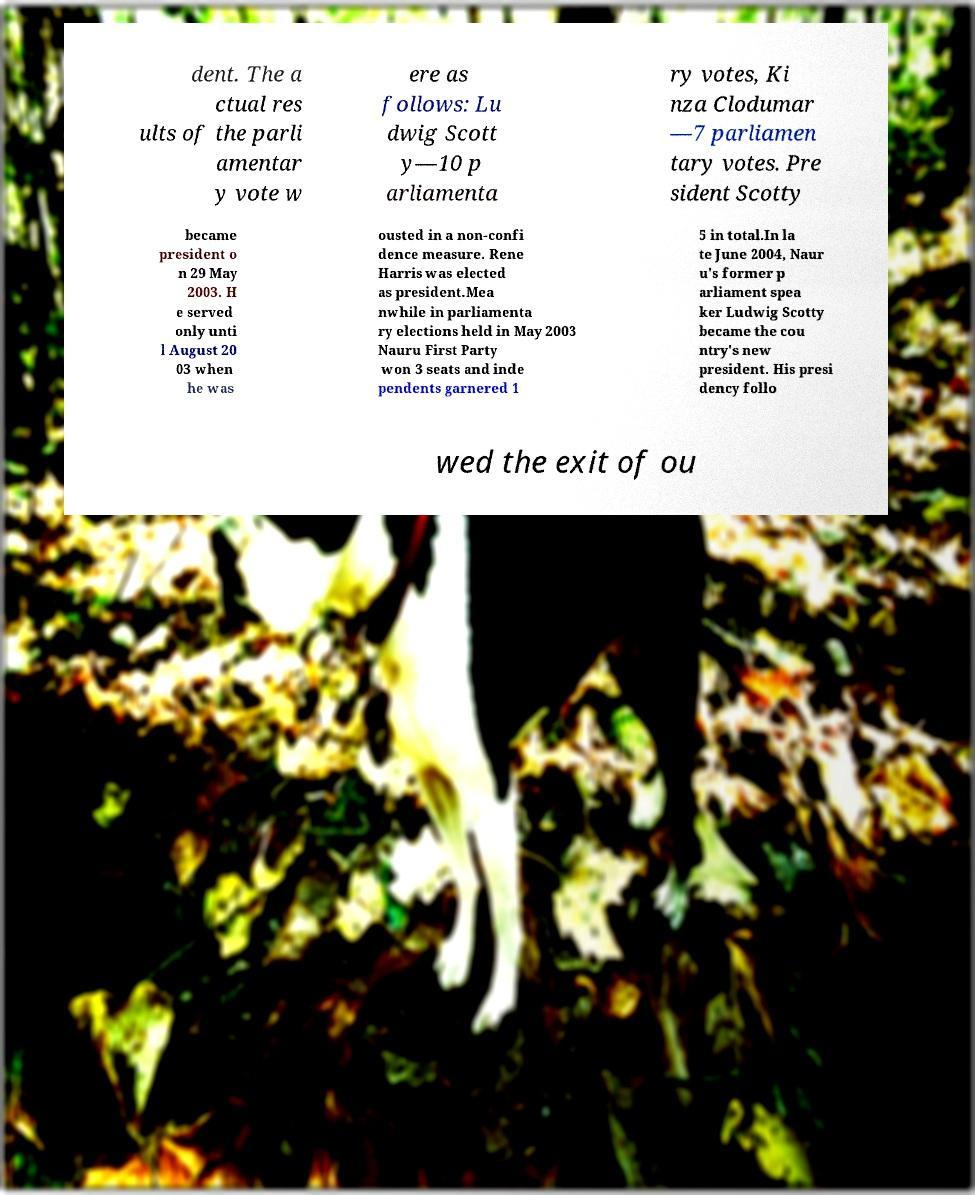Please identify and transcribe the text found in this image. dent. The a ctual res ults of the parli amentar y vote w ere as follows: Lu dwig Scott y—10 p arliamenta ry votes, Ki nza Clodumar —7 parliamen tary votes. Pre sident Scotty became president o n 29 May 2003. H e served only unti l August 20 03 when he was ousted in a non-confi dence measure. Rene Harris was elected as president.Mea nwhile in parliamenta ry elections held in May 2003 Nauru First Party won 3 seats and inde pendents garnered 1 5 in total.In la te June 2004, Naur u's former p arliament spea ker Ludwig Scotty became the cou ntry's new president. His presi dency follo wed the exit of ou 